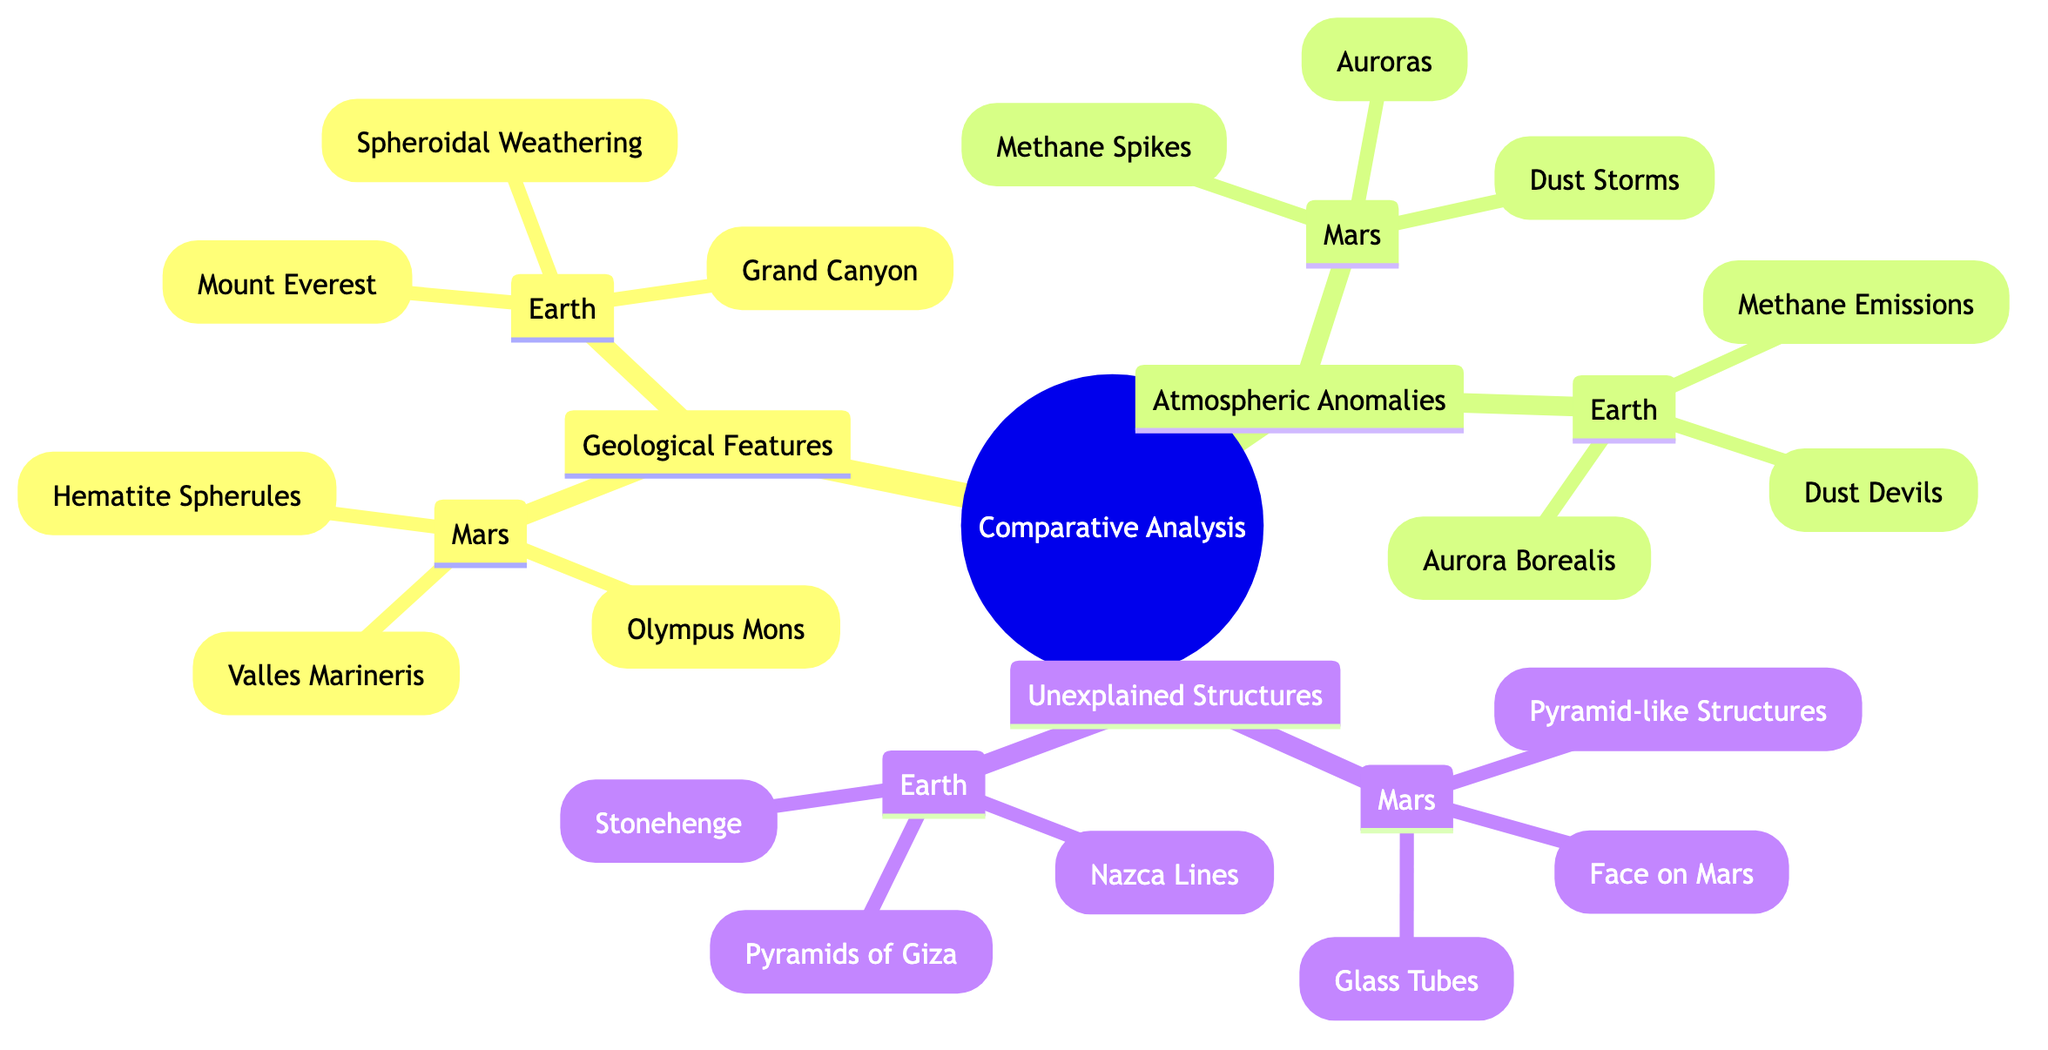What geological features are found on Mars? The diagram lists three geological features for Mars: Olympus Mons, Valles Marineris, and Hematite Spherules.
Answer: Olympus Mons, Valles Marineris, Hematite Spherules What is the number of atmospheric anomalies listed for Earth? In the diagram, there are three atmospheric anomalies provided for Earth: Methane Emissions, Dust Devils, and Aurora Borealis. Thus, the count of these anomalies is 3.
Answer: 3 Which unexplained structure is known for its connection to ancient civilizations on Earth? From the diagram, the Pyramids of Giza are specifically mentioned as an unexplained structure relating to ancient civilizations.
Answer: Pyramids of Giza Compare the types of atmospheric anomalies on Mars and Earth. The diagram shows two columns under Atmospheric Anomalies, detailing that Mars has Methane Spikes, Dust Storms, and Auroras, while Earth has Methane Emissions, Dust Devils, and Aurora Borealis. Both sets address similar atmospheric phenomena but differ in specific examples.
Answer: Similar types of phenomena but different specifics How many geological features does Mars have listed in total? The diagram has three geological features listed under Mars: Olympus Mons, Valles Marineris, and Hematite Spherules. Thus, the total count is 3.
Answer: 3 What is the relationship between the Martian structure "Face on Mars" and its Earth counterpart "Nazca Lines"? The diagram organizes these structures under Unexplained Structures for both Mars and Earth, indicating that "Face on Mars" and "Nazca Lines" serve as examples of mysterious features on separate planets that provoke intrigue and speculation.
Answer: Both are unexplained structures Which asteroid can be linked to both atmospheric anomalies on Mars and Earth? Looking at the atmospheric anomalies in the diagram, the presence of methane in Mars’s Methane Spikes mirrors that of Earth’s Methane Emissions, suggesting a cross-planetary link regarding methane activity.
Answer: Methane List one geological feature on Earth that resembles a canyon. The Grand Canyon is the geological feature listed under Earth that is explicitly defined as a canyon within the diagram.
Answer: Grand Canyon 